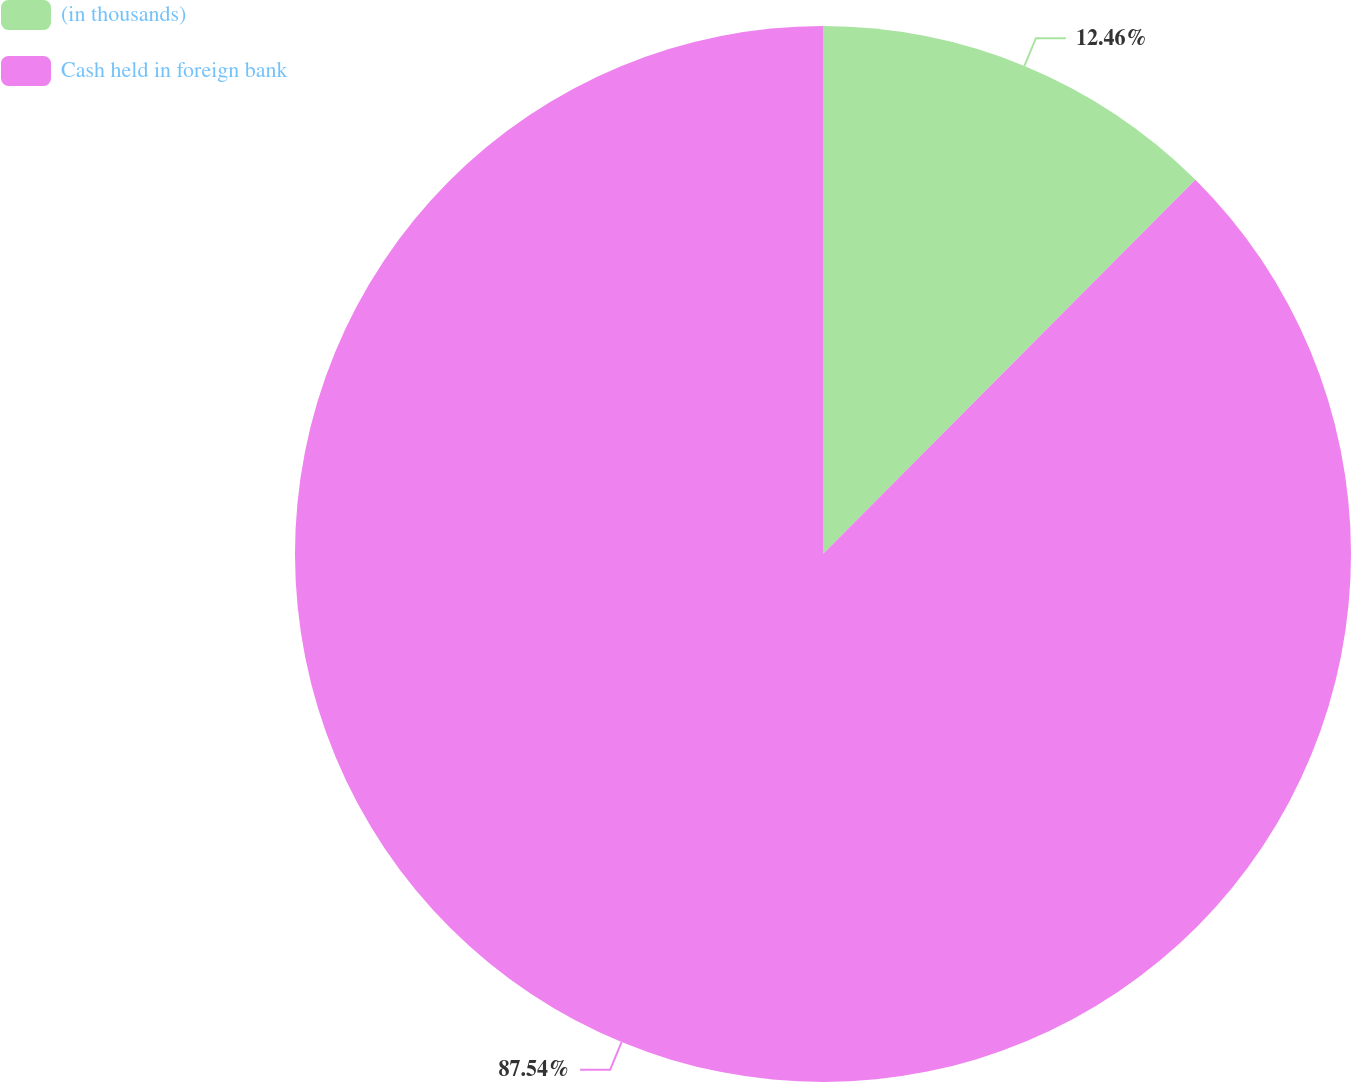Convert chart. <chart><loc_0><loc_0><loc_500><loc_500><pie_chart><fcel>(in thousands)<fcel>Cash held in foreign bank<nl><fcel>12.46%<fcel>87.54%<nl></chart> 